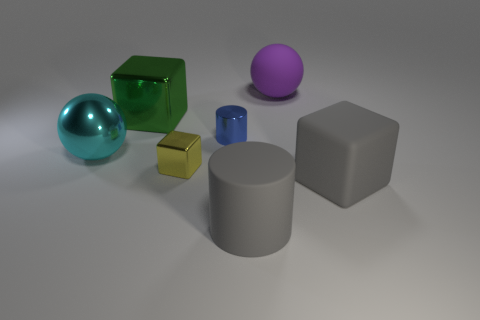What shape is the small blue thing that is the same material as the large green object?
Ensure brevity in your answer.  Cylinder. Are there fewer gray matte objects that are left of the yellow metallic block than small yellow blocks?
Provide a succinct answer. Yes. Is the shape of the large purple matte thing the same as the yellow object?
Give a very brief answer. No. How many matte things are purple spheres or tiny yellow cubes?
Give a very brief answer. 1. Is there a blue metal object of the same size as the yellow metal thing?
Make the answer very short. Yes. What is the shape of the rubber thing that is the same color as the matte cube?
Ensure brevity in your answer.  Cylinder. How many balls have the same size as the matte cylinder?
Keep it short and to the point. 2. There is a gray cylinder that is in front of the large green cube; does it have the same size as the ball to the right of the large cylinder?
Give a very brief answer. Yes. How many things are large red metallic objects or large objects that are behind the tiny cylinder?
Your response must be concise. 2. The metallic cylinder has what color?
Provide a short and direct response. Blue. 